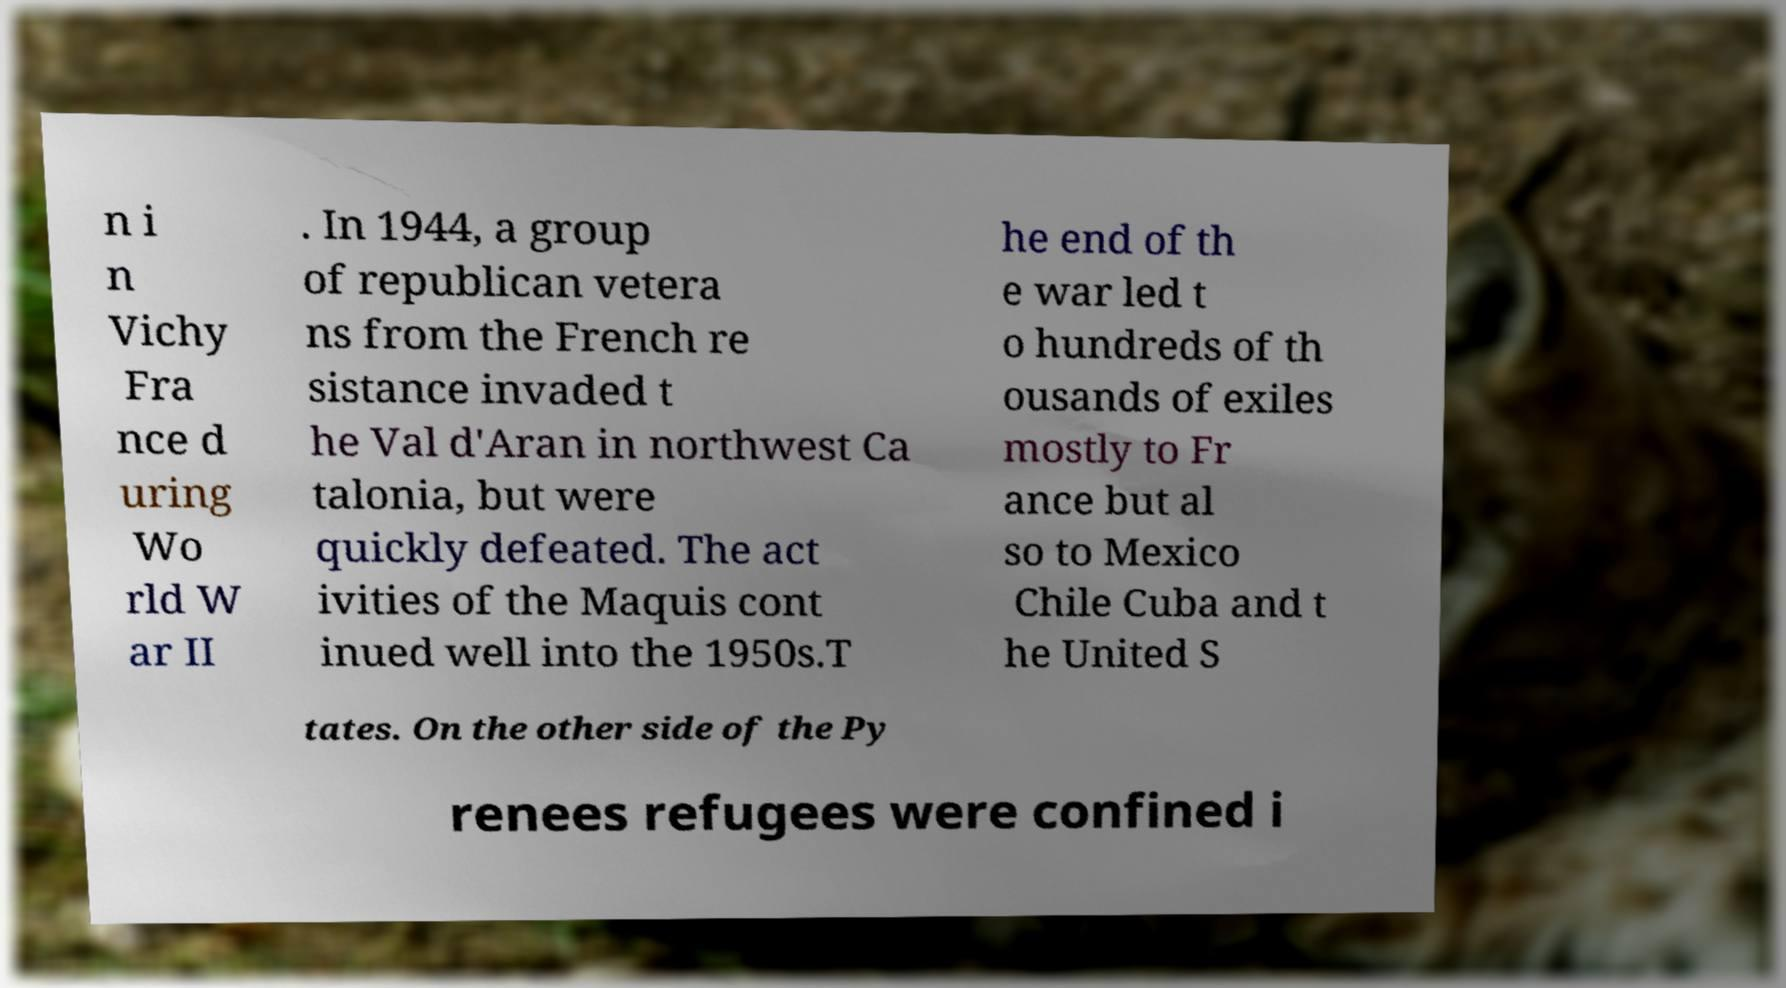I need the written content from this picture converted into text. Can you do that? n i n Vichy Fra nce d uring Wo rld W ar II . In 1944, a group of republican vetera ns from the French re sistance invaded t he Val d'Aran in northwest Ca talonia, but were quickly defeated. The act ivities of the Maquis cont inued well into the 1950s.T he end of th e war led t o hundreds of th ousands of exiles mostly to Fr ance but al so to Mexico Chile Cuba and t he United S tates. On the other side of the Py renees refugees were confined i 